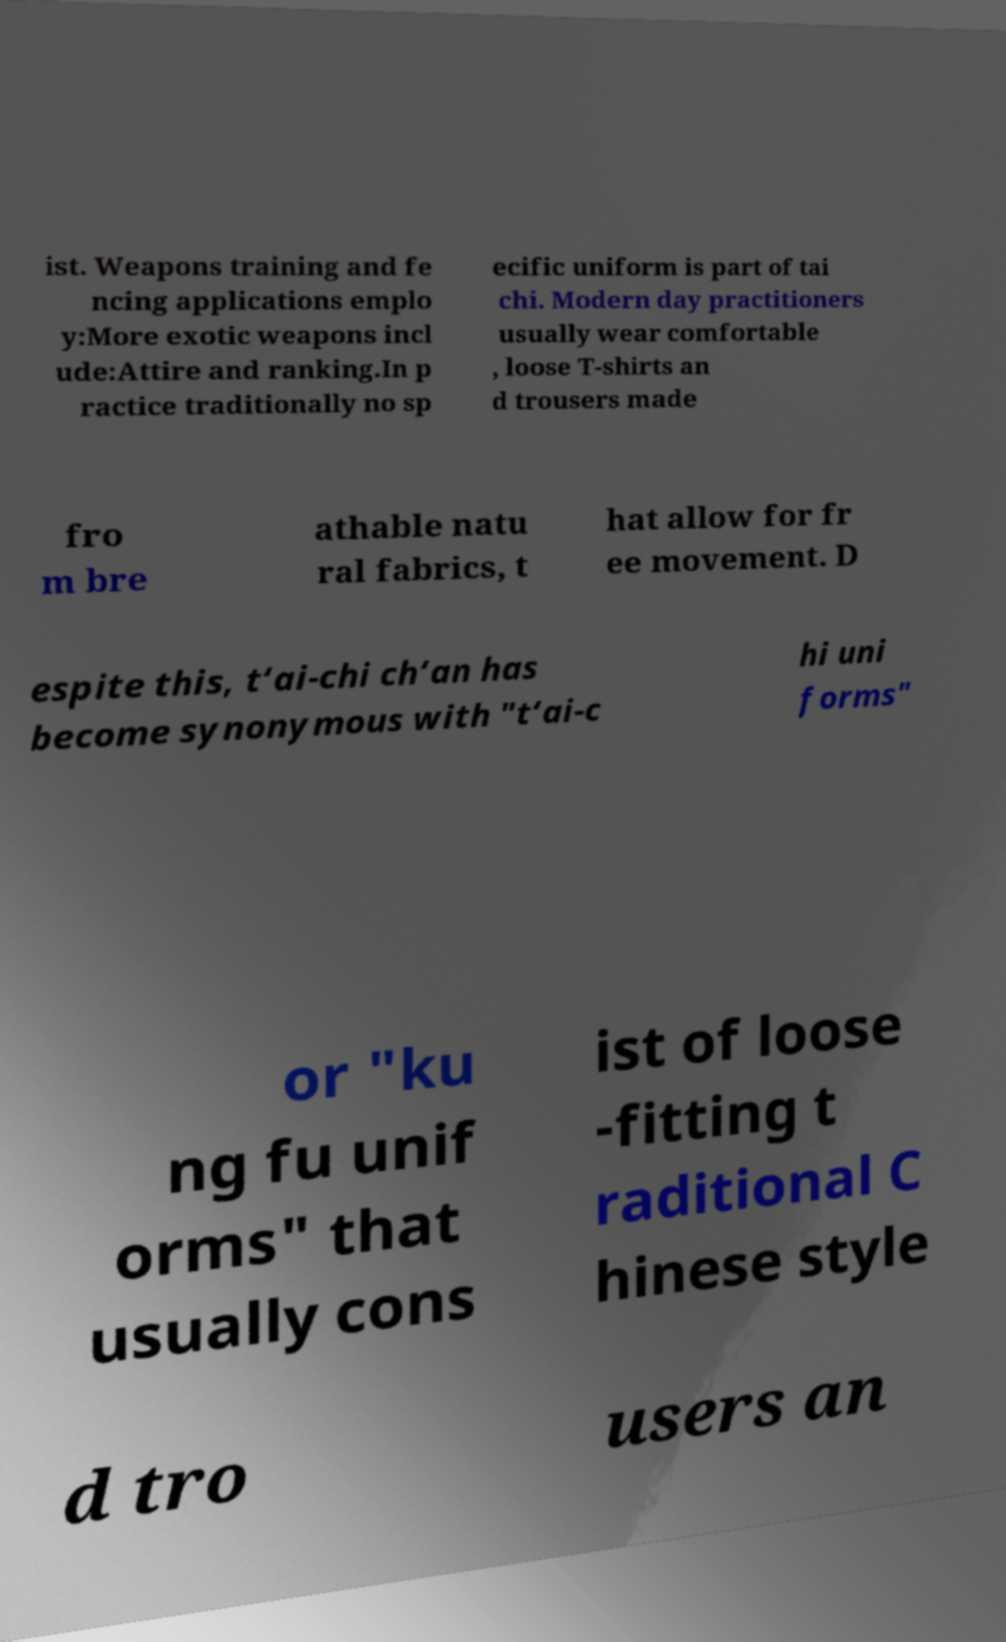Could you assist in decoding the text presented in this image and type it out clearly? ist. Weapons training and fe ncing applications emplo y:More exotic weapons incl ude:Attire and ranking.In p ractice traditionally no sp ecific uniform is part of tai chi. Modern day practitioners usually wear comfortable , loose T-shirts an d trousers made fro m bre athable natu ral fabrics, t hat allow for fr ee movement. D espite this, t‘ai-chi ch‘an has become synonymous with "t‘ai-c hi uni forms" or "ku ng fu unif orms" that usually cons ist of loose -fitting t raditional C hinese style d tro users an 